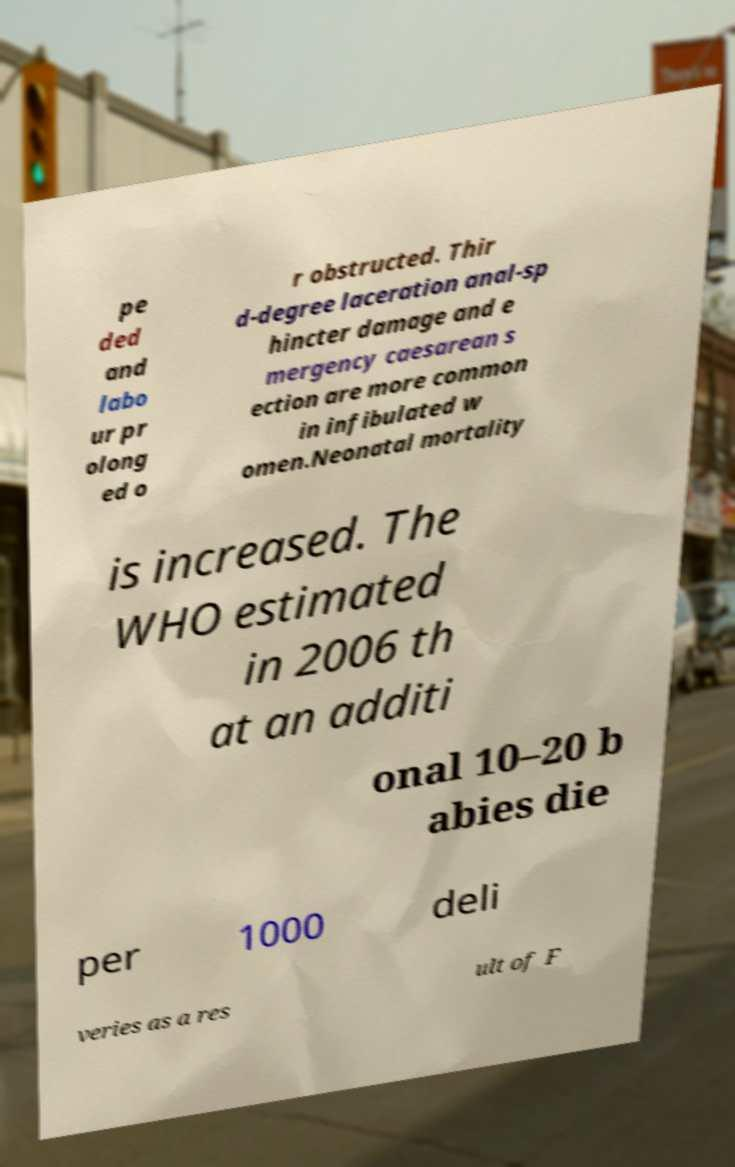Please identify and transcribe the text found in this image. pe ded and labo ur pr olong ed o r obstructed. Thir d-degree laceration anal-sp hincter damage and e mergency caesarean s ection are more common in infibulated w omen.Neonatal mortality is increased. The WHO estimated in 2006 th at an additi onal 10–20 b abies die per 1000 deli veries as a res ult of F 